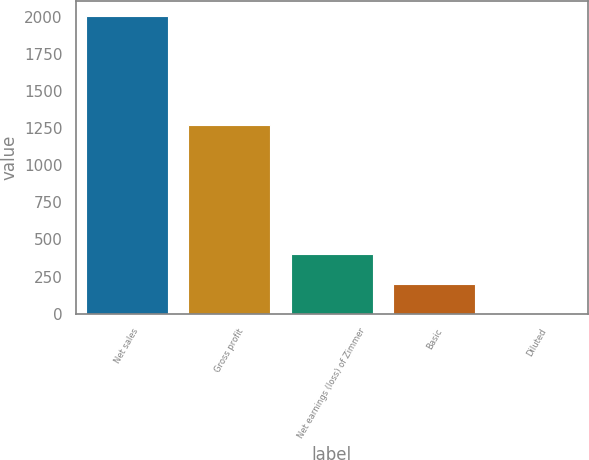Convert chart to OTSL. <chart><loc_0><loc_0><loc_500><loc_500><bar_chart><fcel>Net sales<fcel>Gross profit<fcel>Net earnings (loss) of Zimmer<fcel>Basic<fcel>Diluted<nl><fcel>2007.6<fcel>1274.4<fcel>402.24<fcel>201.57<fcel>0.9<nl></chart> 